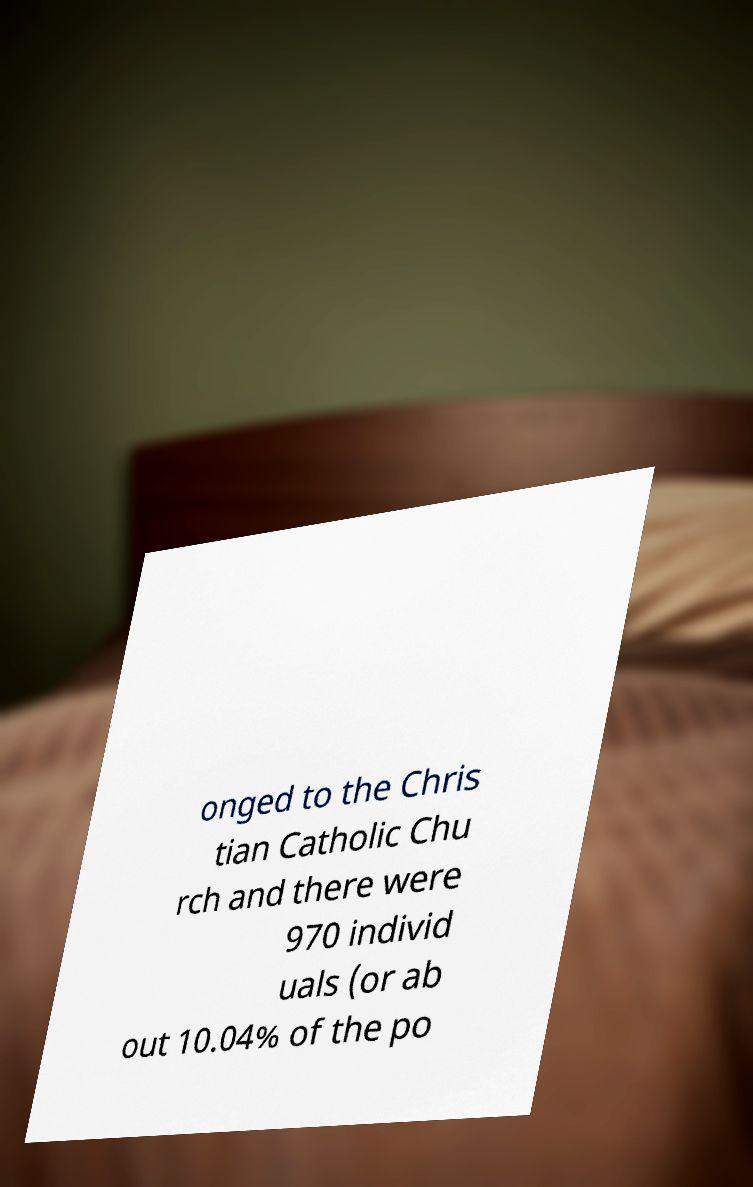Can you accurately transcribe the text from the provided image for me? onged to the Chris tian Catholic Chu rch and there were 970 individ uals (or ab out 10.04% of the po 